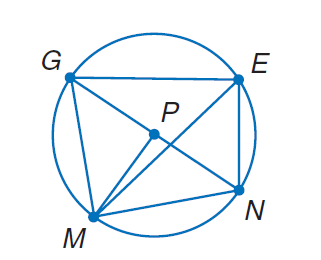Answer the mathemtical geometry problem and directly provide the correct option letter.
Question: In \odot P, m \widehat E N = 66 and m \angle G P M = 89. Find m \angle E G N.
Choices: A: 33 B: 66 C: 89 D: 155 A 